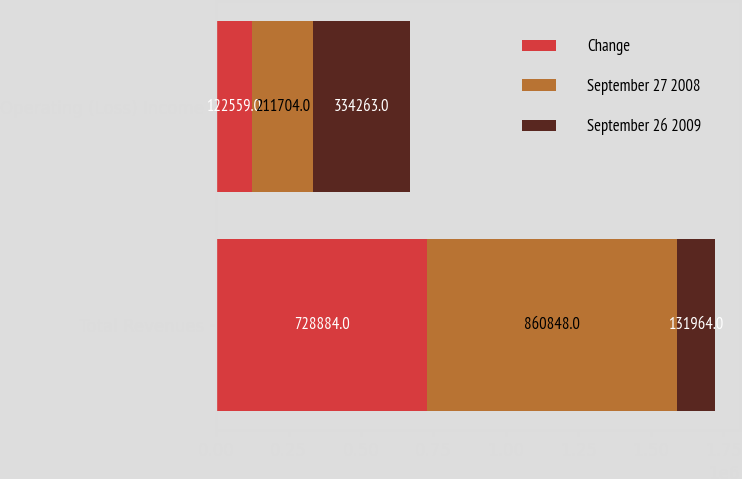Convert chart to OTSL. <chart><loc_0><loc_0><loc_500><loc_500><stacked_bar_chart><ecel><fcel>Total Revenues<fcel>Operating (Loss) Income<nl><fcel>Change<fcel>728884<fcel>122559<nl><fcel>September 27 2008<fcel>860848<fcel>211704<nl><fcel>September 26 2009<fcel>131964<fcel>334263<nl></chart> 